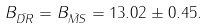<formula> <loc_0><loc_0><loc_500><loc_500>B _ { \bar { D R } } = B _ { \bar { M S } } = 1 3 . 0 2 \pm 0 . 4 5 .</formula> 